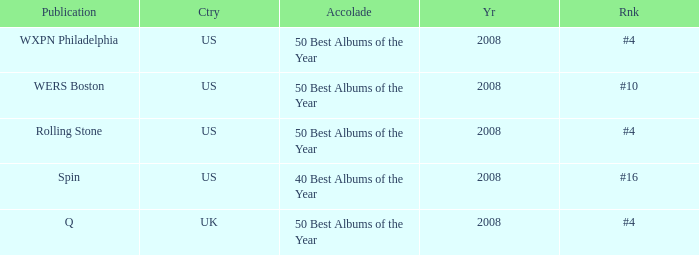Which publication happened in the UK? Q. 